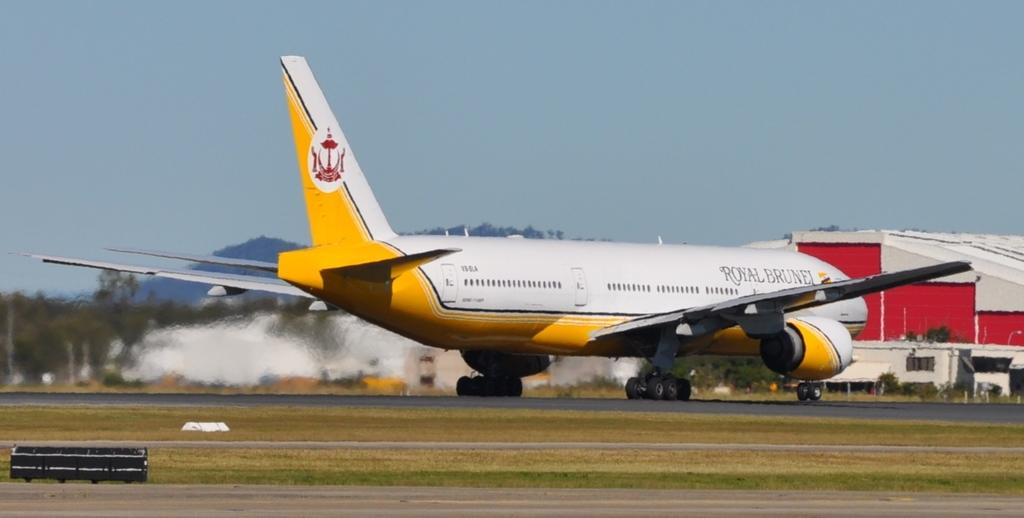<image>
Share a concise interpretation of the image provided. a plane that is yellow and white owned by Royal Brunel 